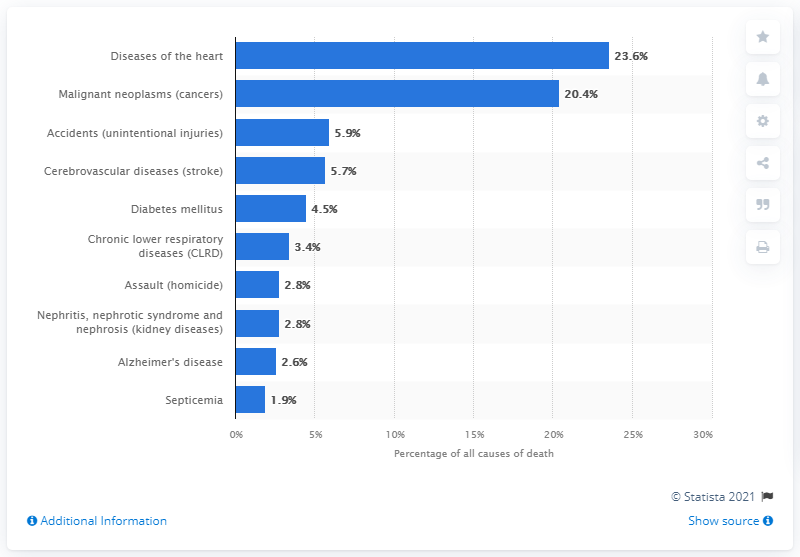List a handful of essential elements in this visual. According to data from 2018, the leading cause of death among Black residents in the United States is diseases of the heart. The total percentage of deaths combined due to assault and septicemia is 4.7%. 